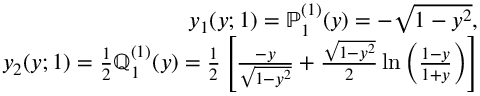<formula> <loc_0><loc_0><loc_500><loc_500>\begin{array} { r l r } & { y _ { 1 } ( y ; 1 ) = \mathbb { P } _ { 1 } ^ { ( 1 ) } ( y ) = - \sqrt { 1 - y ^ { 2 } } , } \\ & { y _ { 2 } ( y ; 1 ) = \frac { 1 } { 2 } \mathbb { Q } _ { 1 } ^ { ( 1 ) } ( y ) = \frac { 1 } { 2 } \left [ \frac { - y } { \sqrt { 1 - y ^ { 2 } } } + \frac { \sqrt { 1 - y ^ { 2 } } } { 2 } \ln \left ( \frac { 1 - y } { 1 + y } \right ) \right ] } \end{array}</formula> 